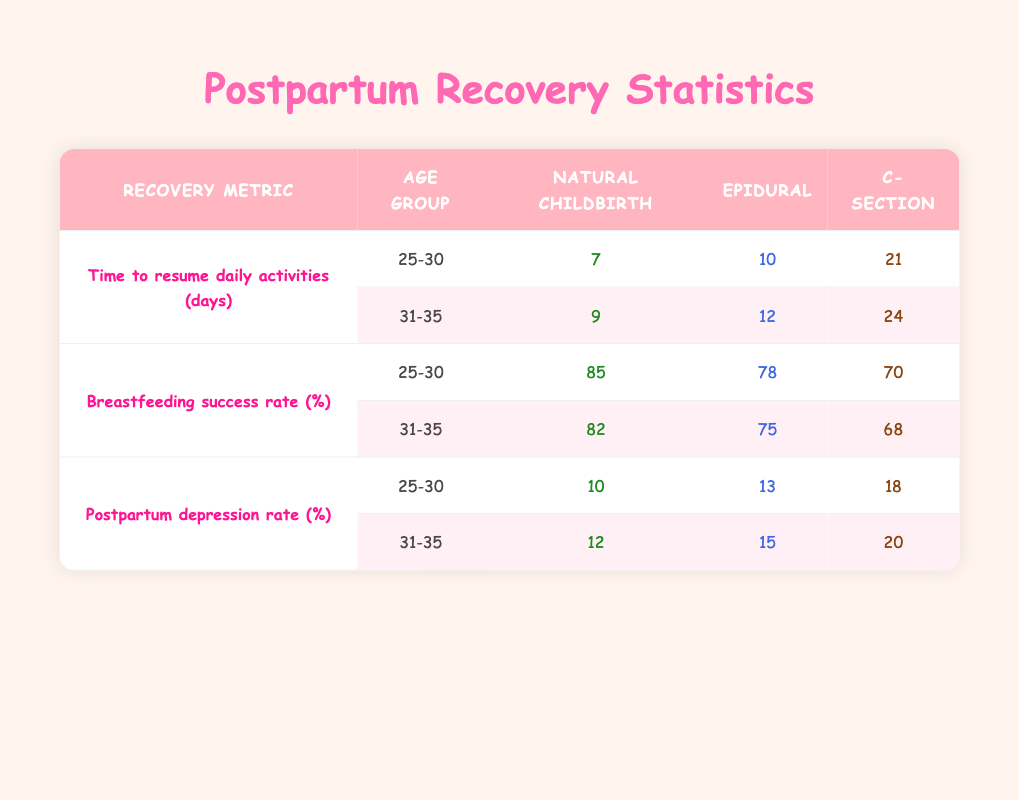What is the time to resume daily activities for women aged 25-30 who had natural childbirth? The table shows that for the age group 25-30 under natural childbirth, the time to resume daily activities is 7 days.
Answer: 7 days What is the breastfeeding success rate for women aged 31-35 who had a C-section? According to the table, for women aged 31-35 who had a C-section, the breastfeeding success rate is 68%.
Answer: 68% True or False: The postpartum depression rate for women who had an epidural is higher than for those who had natural childbirth in the 25-30 age group. The table indicates 13% for epidural and 10% for natural childbirth in the 25-30 age group. Since 13% is greater than 10%, the statement is true.
Answer: True What is the difference in time to resume daily activities between C-section and natural childbirth for age group 31-35? The time for natural childbirth in the 31-35 age group is 9 days, and for C-section, it is 24 days. The difference is 24 - 9 = 15 days.
Answer: 15 days What is the average postpartum depression rate for women aged 25-30 across all birthing approaches? The postpartum depression rates for 25-30 years old are as follows: Natural Childbirth (10%), Epidural (13%), and C-section (18%). To find the average, sum them: 10 + 13 + 18 = 41, then divide by the number of approaches (3): 41 / 3 ≈ 13.67%.
Answer: 13.67% What is the breastfeeding success rate for the age group 25-30 across all birthing approaches? For the age group 25-30, the rates are: Natural Childbirth (85%), Epidural (78%), and C-section (70%). The combined average is (85 + 78 + 70) / 3 = 77.67%.
Answer: 77.67% Which birthing approach has the highest breastfeeding success rate for the age group 31-35? In the age group 31-35, the breastfeeding success rates are: Natural Childbirth (82%), Epidural (75%), and C-section (68%). Natural Childbirth has the highest success rate.
Answer: Natural Childbirth What is the recovery metric with the highest value for women aged 31-35? For the age group 31-35, the recovery metrics are: Time to resume activities (24 days for C-section), Breastfeeding success rate (68% for C-section), and Postpartum depression rate (20% for C-section). The highest value is 24 days for C-section.
Answer: 24 days 